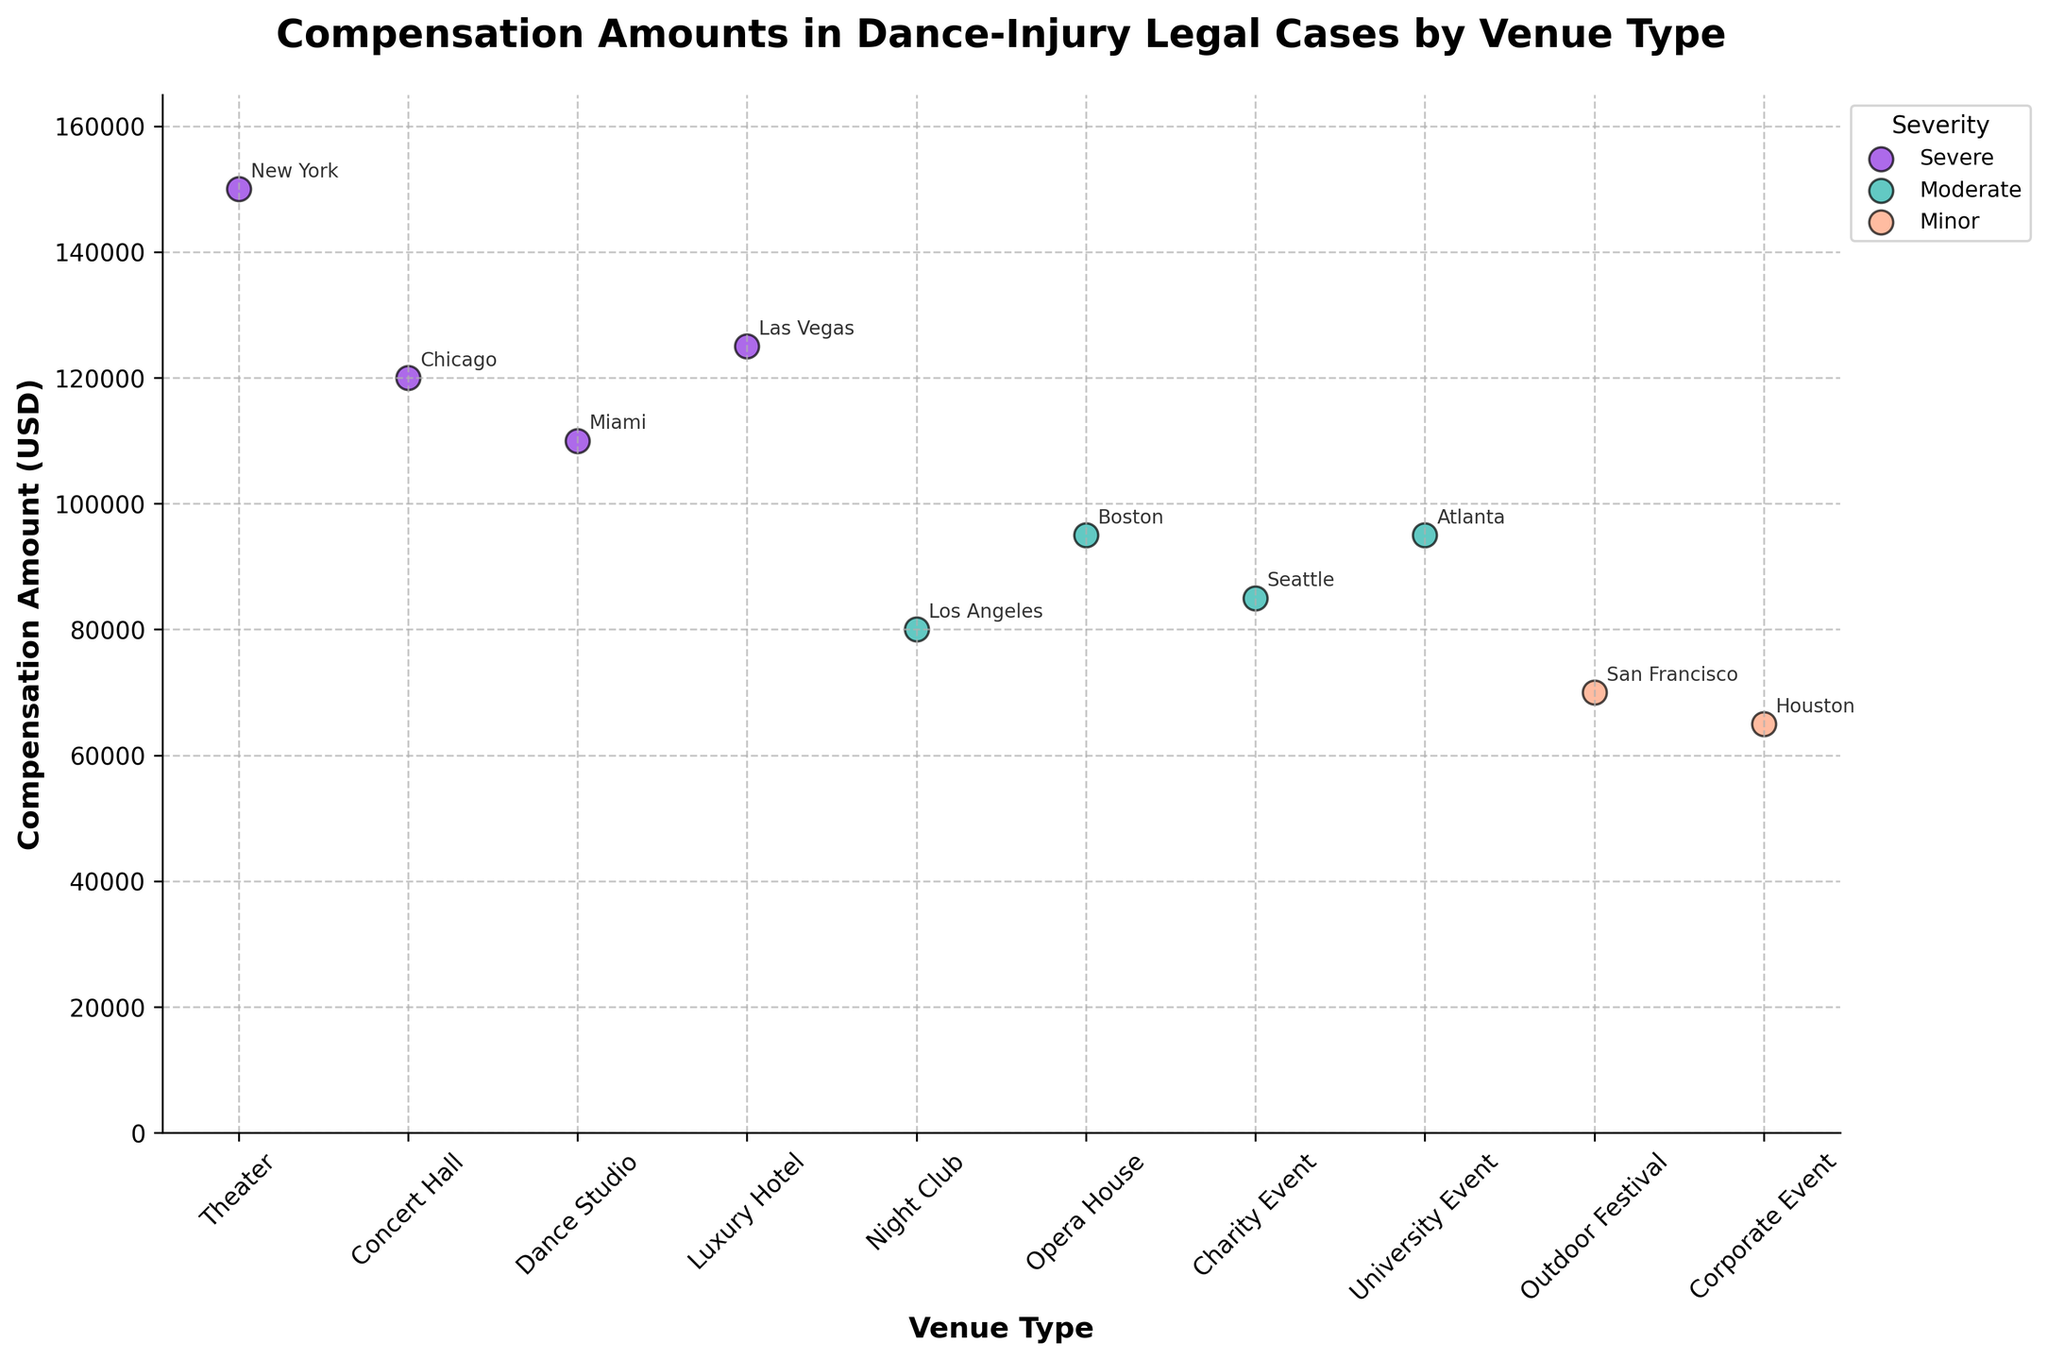What's the title of this figure? The title is written at the top of the plot, indicating what the scatter plot represents. It reads, "Compensation Amounts in Dance-Injury Legal Cases by Venue Type."
Answer: Compensation Amounts in Dance-Injury Legal Cases by Venue Type What is the highest compensation amount shown in the plot? By looking at the y-axis and the data points, the highest compensation amount corresponds to the data point which is closest to the maximum of the y-axis. This max value is noted near the top of the axis.
Answer: 150,000 USD What venue type has the lowest compensation amount? To find the lowest compensation amount, look at the data points closest to the bottom of the y-axis and identify the corresponding venue type.
Answer: Corporate Event How many venue types have a compensation amount greater than 100,000 USD? Count the number of data points that lie above the 100,000 USD mark on the y-axis and note their corresponding venue types. There are data points near the top part of the axis.
Answer: 4 Which severity level has the highest compensation amount, and what is that amount? The highest compensation amount on the plot corresponds to a specific data point, which is colored in a way that indicates its severity. Match the color with the legend to find its severity.
Answer: Severe, 150,000 USD What is the total compensation amount for all "Moderate" severity cases? Identify the data points labeled with "Moderate" severity in the plot and sum their compensation amounts. The relevant amounts are 80,000, 95,000, 95,000, and 85,000 USD. Calculating: 80,000 + 95,000 + 95,000 + 85,000 = 355,000 USD.
Answer: 355,000 USD Which venue type in a severe case has the maximum compensation amount? Look at the data points labeled with "Severe" severity and find the one with the highest compensation by comparing their y-axis positions.
Answer: Theater What is the average compensation amount for "Minor" severity cases? Determine the compensation amounts for all data points with "Minor" severity and calculate their average. The amounts are 70,000 and 65,000 USD. Calculating: (70,000 + 65,000) / 2 = 67,500 USD.
Answer: 67,500 USD Between "Night Club" and "Luxury Hotel", which venue type has a higher compensation amount? Compare the compensation amounts for "Night Club" and "Luxury Hotel" based on their positions on the y-axis.
Answer: Luxury Hotel How many different locations are represented in the plot? Count the number of unique locations labeled on the plot by identifying each annotation beside the data points.
Answer: 10 